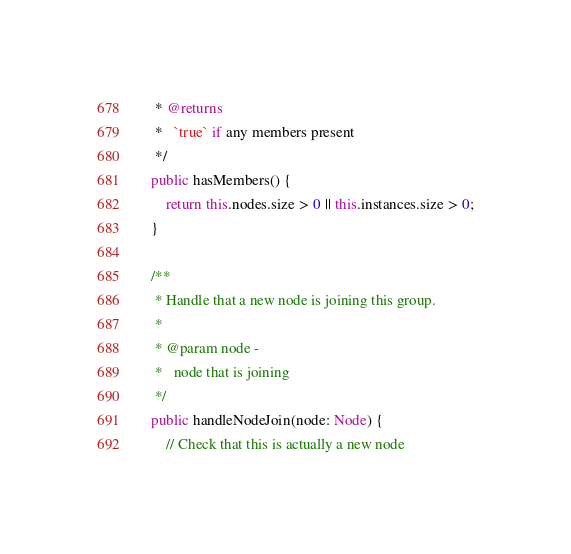<code> <loc_0><loc_0><loc_500><loc_500><_TypeScript_>	 * @returns
	 *   `true` if any members present
	 */
	public hasMembers() {
		return this.nodes.size > 0 || this.instances.size > 0;
	}

	/**
	 * Handle that a new node is joining this group.
	 *
	 * @param node -
	 *   node that is joining
	 */
	public handleNodeJoin(node: Node) {
		// Check that this is actually a new node</code> 